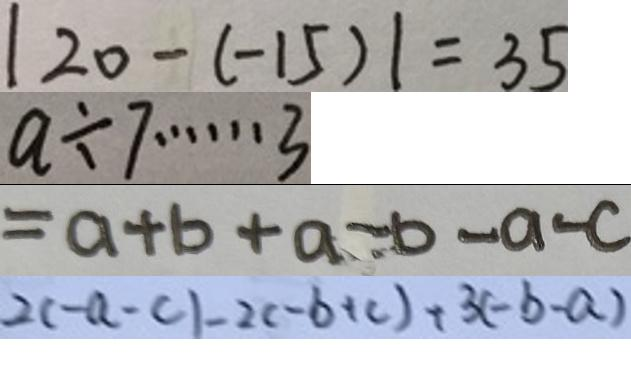Convert formula to latex. <formula><loc_0><loc_0><loc_500><loc_500>\vert 2 0 - ( - 1 5 ) \vert = 3 5 
 a \div 7 \cdots 3 
 = a + b + a - b - a - c 
 2 ( - a - c ) - 2 ( - b + c ) + 3 ( - b - a )</formula> 